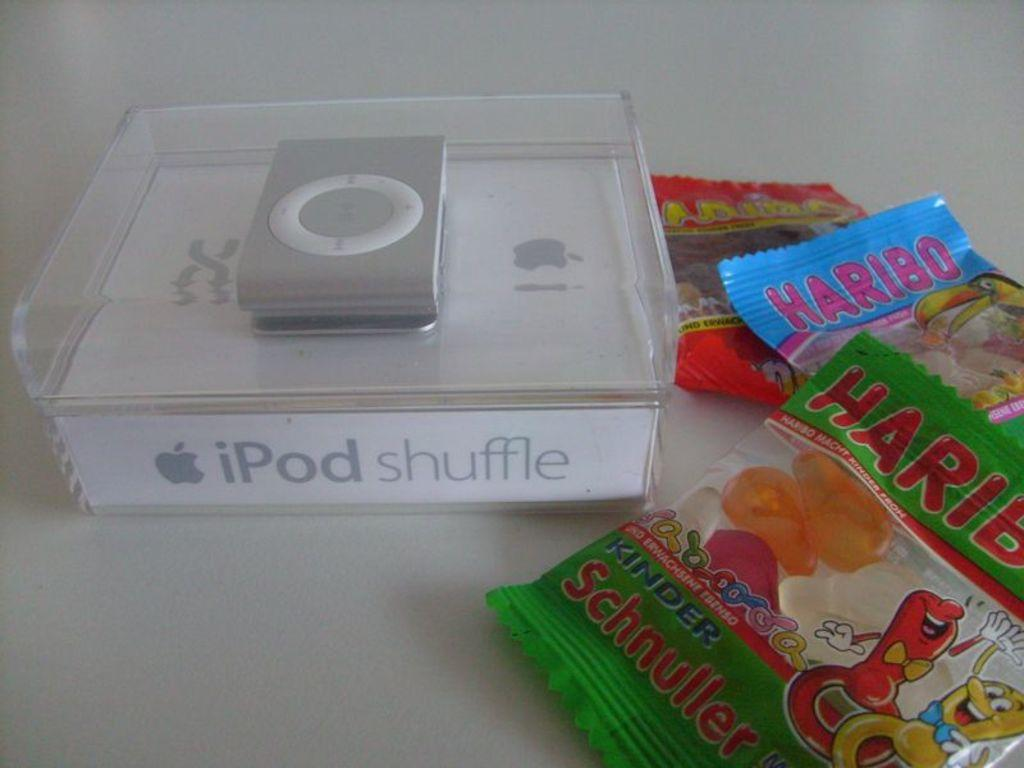What electronic device is visible in the image? There is an iPod in the image. How is the iPod being stored or protected in the image? The iPod is in a plastic box in the image. What type of accessories are present in the image? There are plastic covers visible in the image. Where are the plastic covers located? The plastic covers are on a table in the image. How many beams of light can be seen coming from the iPod in the image? There are no beams of light visible in the image; the iPod is in a plastic box. 